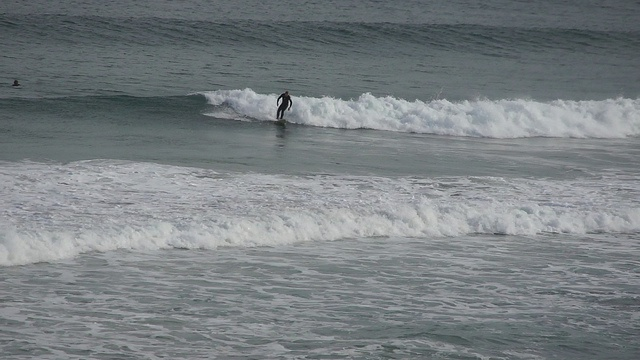Describe the objects in this image and their specific colors. I can see people in gray, black, purple, and darkgray tones and surfboard in gray and black tones in this image. 